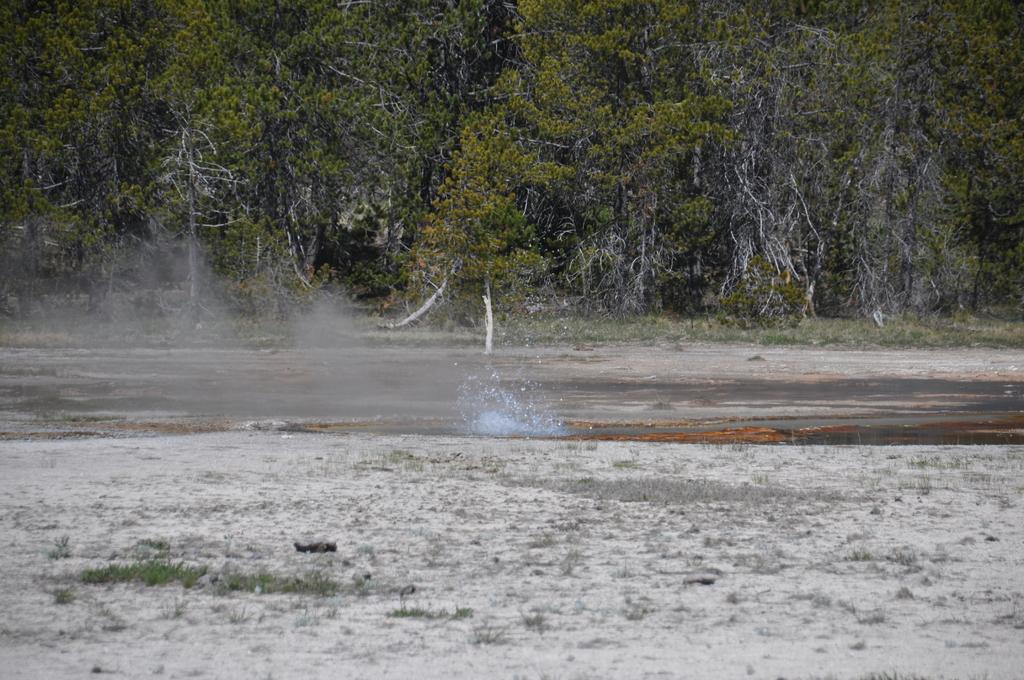What types of terrain are visible at the bottom of the picture? There is sand and grass at the bottom of the picture. What is located in the middle of the picture? There is water in the middle of the picture. What can be seen in the background of the picture? There are trees in the background of the picture. What committee is meeting on the sand in the image? There is no committee present in the image; it features sand, grass, water, and trees. How many times does the grass fold over in the image? The grass does not fold over in the image; it is depicted as individual blades. 